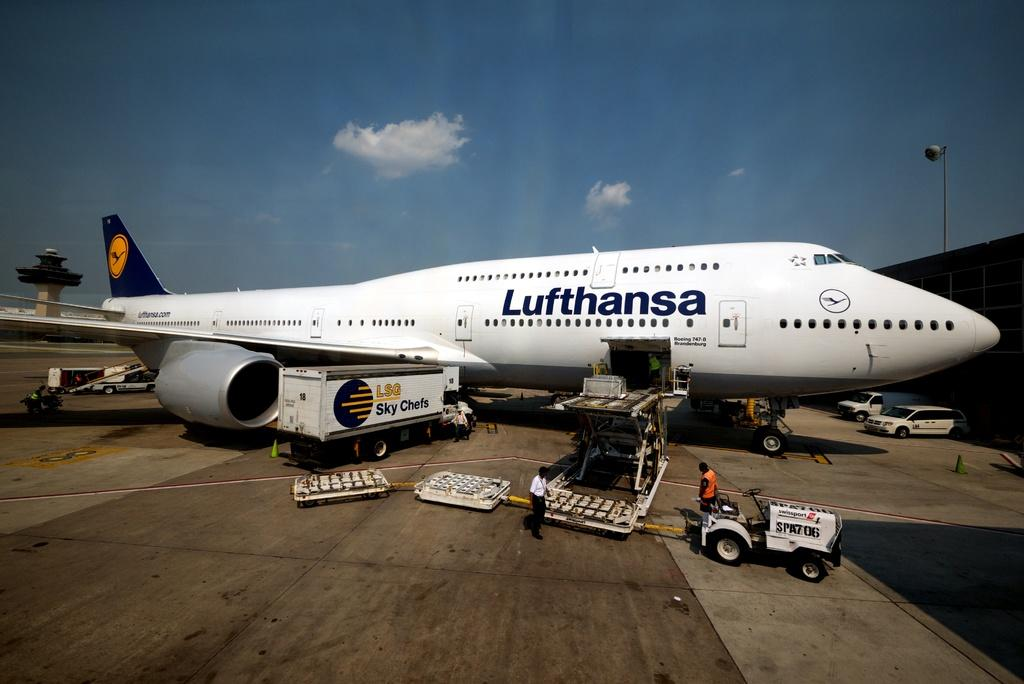<image>
Render a clear and concise summary of the photo. The Lufthansa plane is bing loaded with something. 